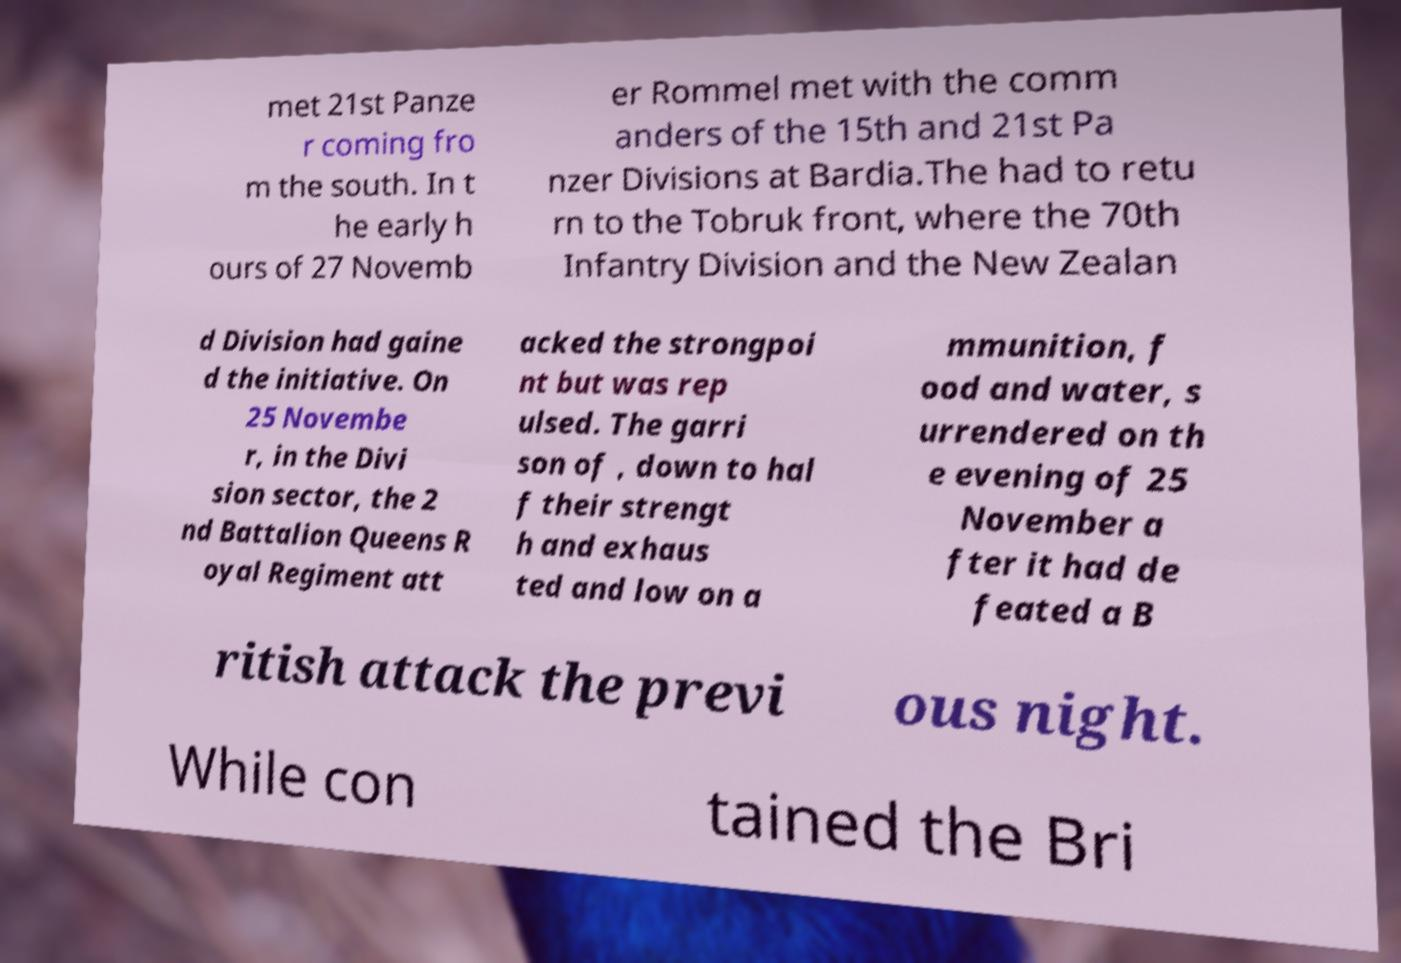What messages or text are displayed in this image? I need them in a readable, typed format. met 21st Panze r coming fro m the south. In t he early h ours of 27 Novemb er Rommel met with the comm anders of the 15th and 21st Pa nzer Divisions at Bardia.The had to retu rn to the Tobruk front, where the 70th Infantry Division and the New Zealan d Division had gaine d the initiative. On 25 Novembe r, in the Divi sion sector, the 2 nd Battalion Queens R oyal Regiment att acked the strongpoi nt but was rep ulsed. The garri son of , down to hal f their strengt h and exhaus ted and low on a mmunition, f ood and water, s urrendered on th e evening of 25 November a fter it had de feated a B ritish attack the previ ous night. While con tained the Bri 